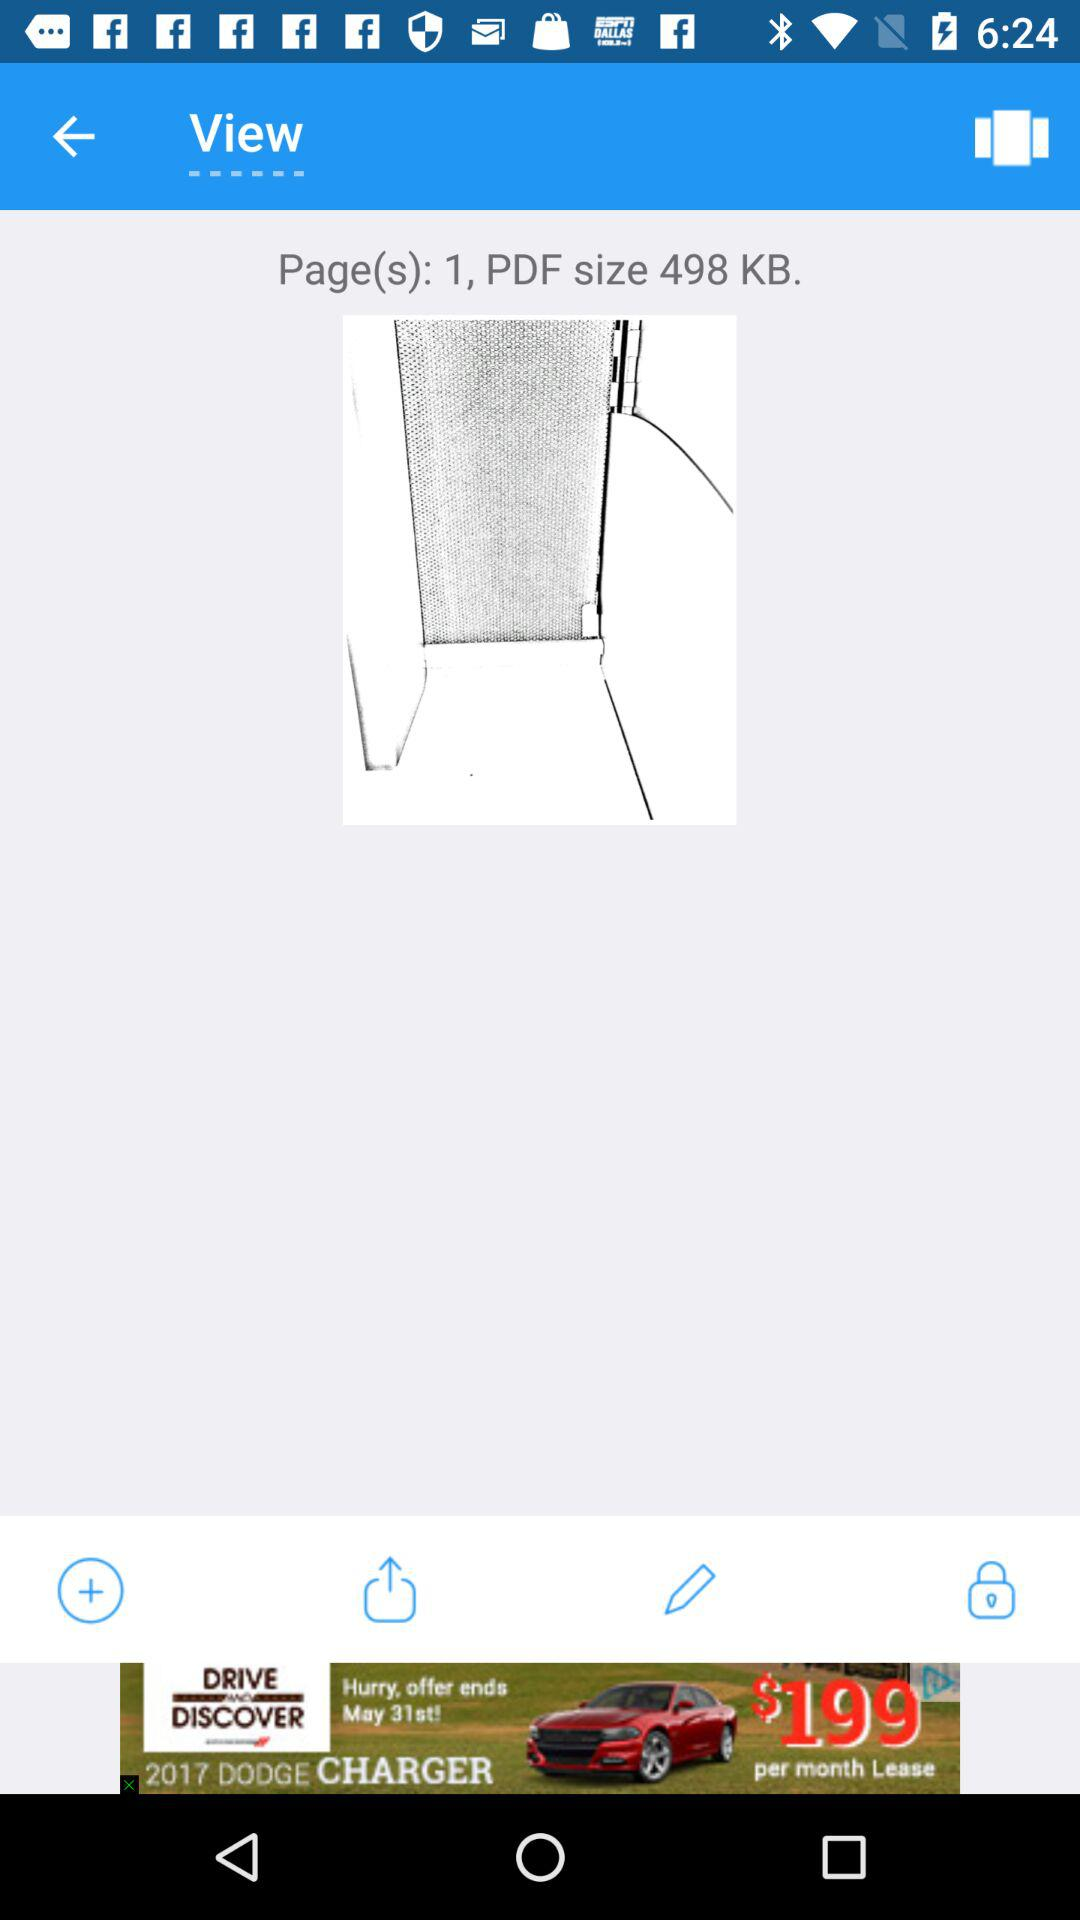What is the size of the PDF file in KB?
Answer the question using a single word or phrase. 498 